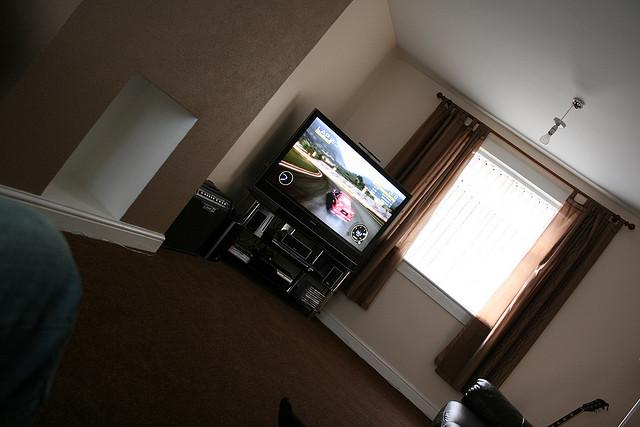What type of game is being played? Please explain your reasoning. video. A screenshot of a car on a track is seen on a television. there are many racing video games. 